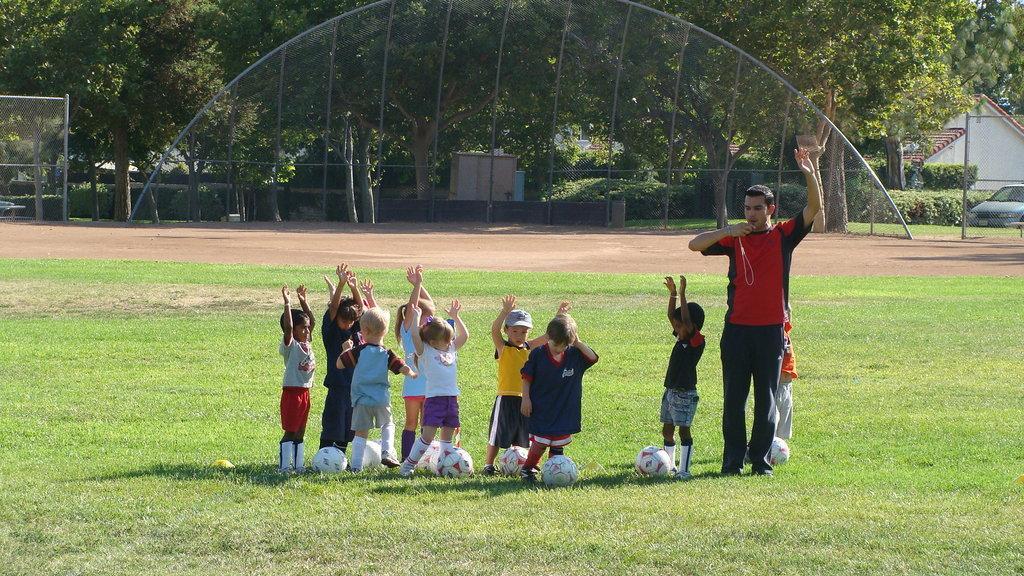In one or two sentences, can you explain what this image depicts? In this picture we can see there are groups of kids and a man is standing on the path and on the path there are balls. Behind the people there are trees, plants, vehicle, house and other things. 